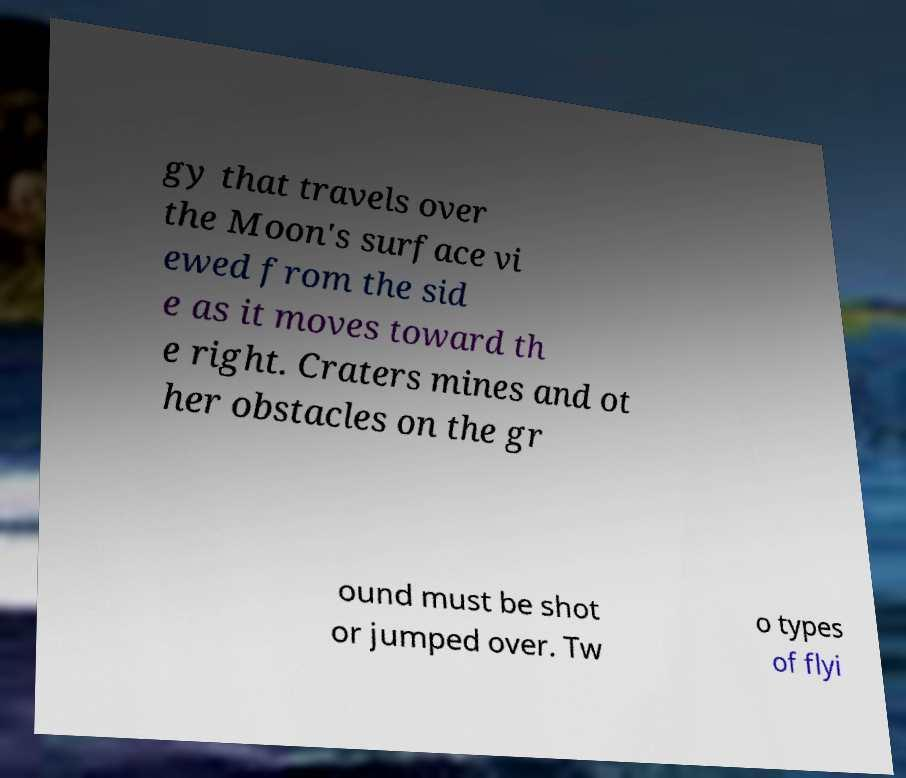Can you accurately transcribe the text from the provided image for me? gy that travels over the Moon's surface vi ewed from the sid e as it moves toward th e right. Craters mines and ot her obstacles on the gr ound must be shot or jumped over. Tw o types of flyi 